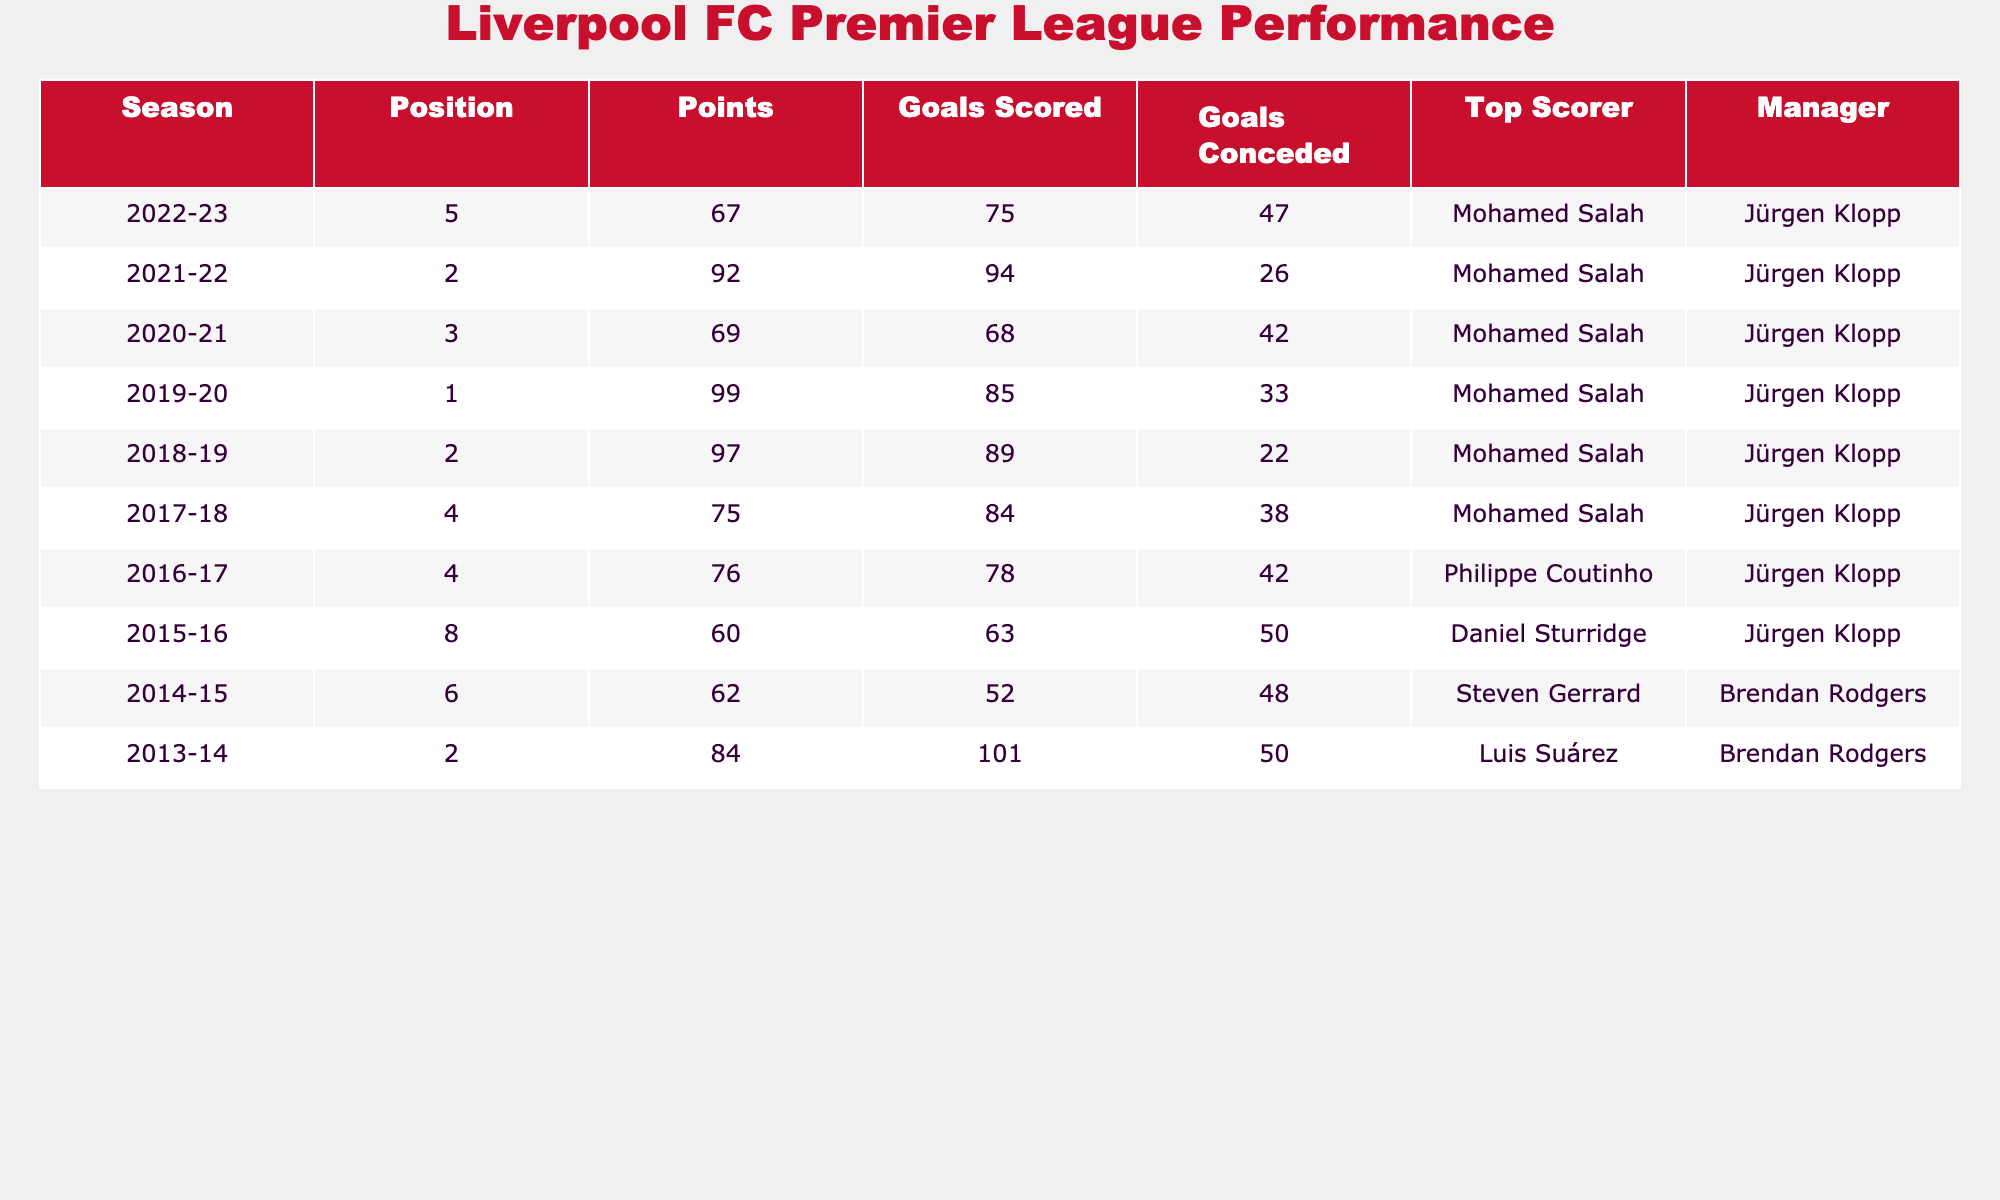What was Liverpool's highest finish in the Premier League in the past decade? Liverpool achieved their highest finish of 1st place during the 2019-20 season.
Answer: 1st Who was the top scorer for Liverpool in the 2021-22 season? The top scorer for Liverpool in the 2021-22 season was Mohamed Salah.
Answer: Mohamed Salah How many points did Liverpool earn in the 2018-19 season? Liverpool earned 97 points in the 2018-19 season, as indicated in the table.
Answer: 97 What is the average number of goals conceded by Liverpool over the last decade? To calculate the average, sum the goals conceded (47 + 26 + 42 + 33 + 22 + 38 + 42 + 50 + 48 + 50) = 398. Since there are 10 seasons, the average is 398/10 = 39.8.
Answer: 39.8 Did Liverpool finish in the top four every season in the last decade? No, Liverpool did not finish in the top four every season; they finished 8th in the 2015-16 season.
Answer: No What was the difference in points between the 2022-23 season and the 2019-20 season? Liverpool had 67 points in the 2022-23 season and 99 points in the 2019-20 season. The difference is 99 - 67 = 32 points.
Answer: 32 Which manager was in charge for Liverpool's highest finish, and what year was it? Jürgen Klopp was the manager during Liverpool's highest finish (1st place) in the 2019-20 season.
Answer: Jürgen Klopp; 2019-20 How many seasons did Liverpool score more than 80 goals? Liverpool scored more than 80 goals in four seasons: 2013-14 (101 goals), 2018-19 (89 goals), 2019-20 (85 goals), and 2021-22 (94 goals).
Answer: 4 What was the position of Liverpool in the 2016-17 season and how many points did they have? In the 2016-17 season, Liverpool finished in 4th position with 76 points.
Answer: 4th, 76 points 